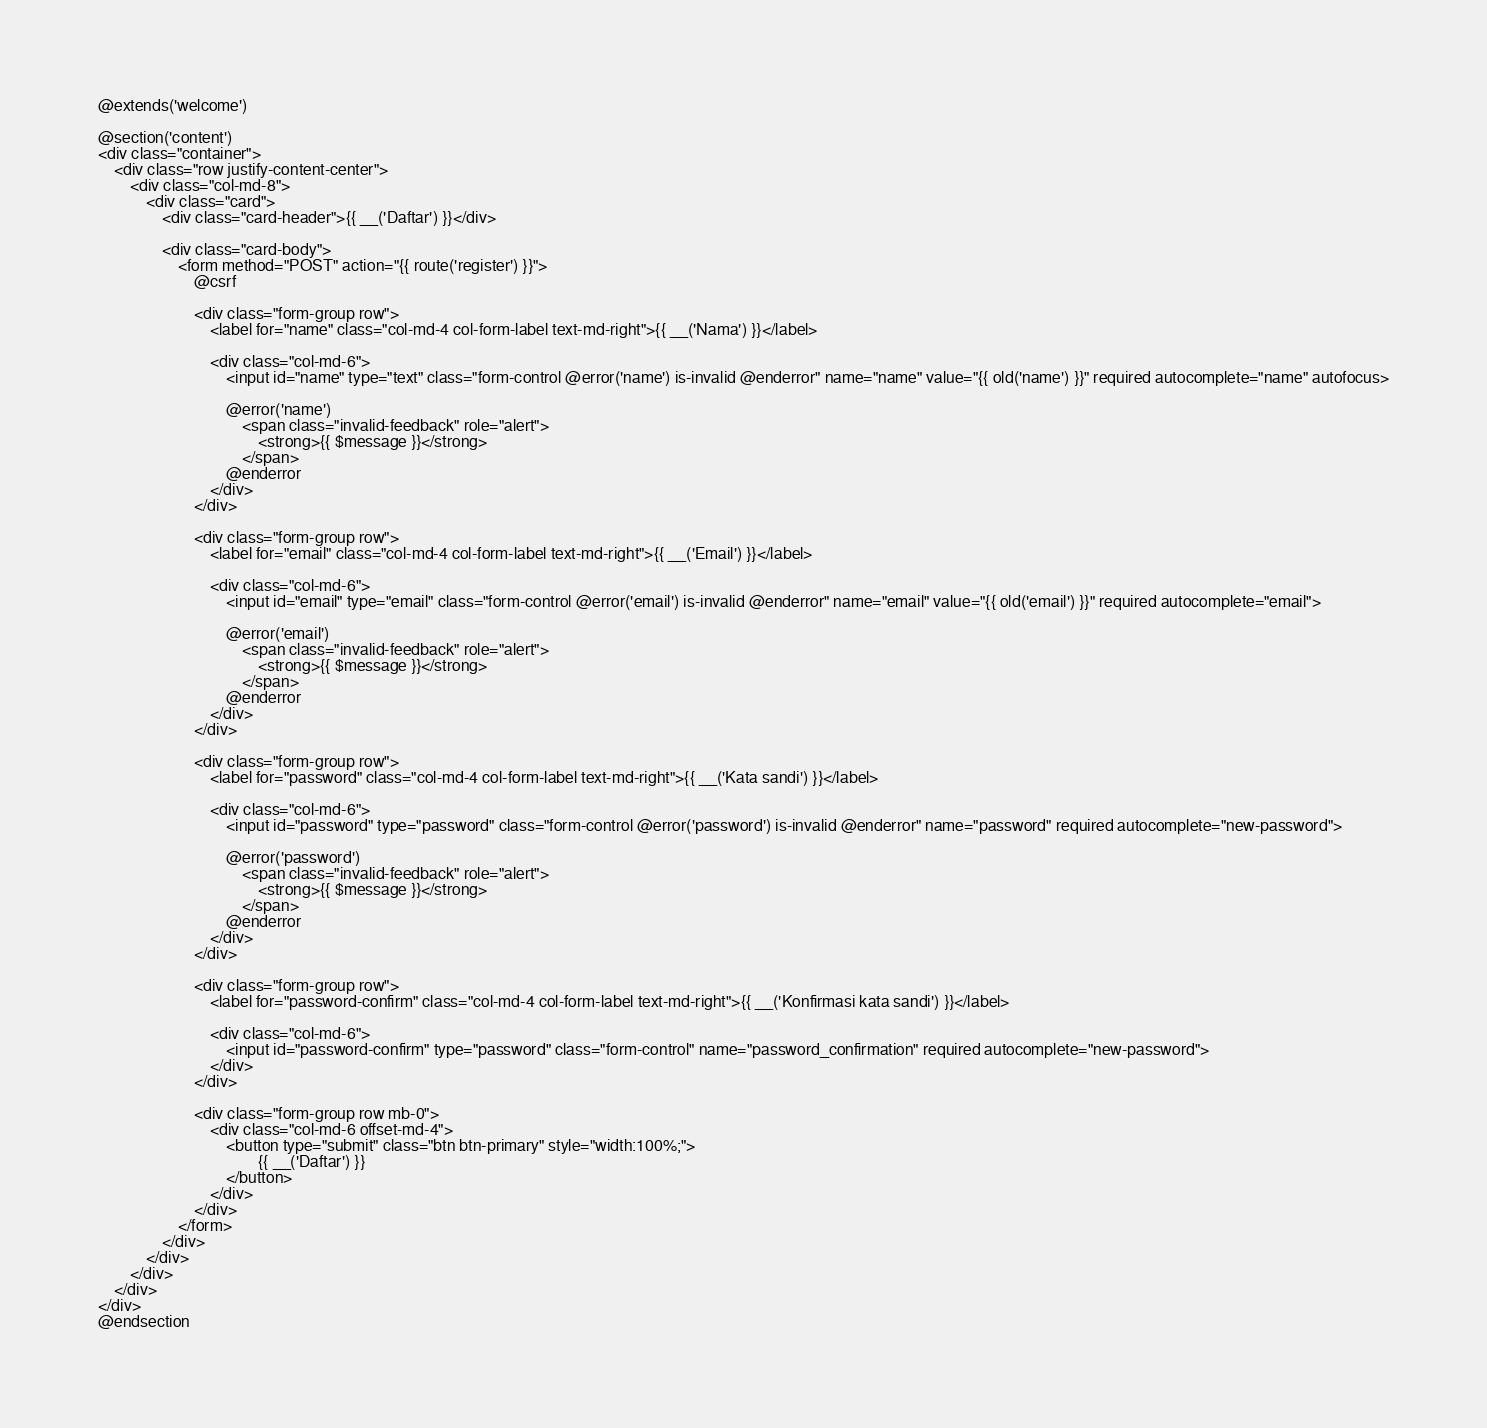Convert code to text. <code><loc_0><loc_0><loc_500><loc_500><_PHP_>@extends('welcome')

@section('content')
<div class="container">
    <div class="row justify-content-center">
        <div class="col-md-8">
            <div class="card">
                <div class="card-header">{{ __('Daftar') }}</div>

                <div class="card-body">
                    <form method="POST" action="{{ route('register') }}">
                        @csrf

                        <div class="form-group row">
                            <label for="name" class="col-md-4 col-form-label text-md-right">{{ __('Nama') }}</label>

                            <div class="col-md-6">
                                <input id="name" type="text" class="form-control @error('name') is-invalid @enderror" name="name" value="{{ old('name') }}" required autocomplete="name" autofocus>

                                @error('name')
                                    <span class="invalid-feedback" role="alert">
                                        <strong>{{ $message }}</strong>
                                    </span>
                                @enderror
                            </div>
                        </div>

                        <div class="form-group row">
                            <label for="email" class="col-md-4 col-form-label text-md-right">{{ __('Email') }}</label>

                            <div class="col-md-6">
                                <input id="email" type="email" class="form-control @error('email') is-invalid @enderror" name="email" value="{{ old('email') }}" required autocomplete="email">

                                @error('email')
                                    <span class="invalid-feedback" role="alert">
                                        <strong>{{ $message }}</strong>
                                    </span>
                                @enderror
                            </div>
                        </div>

                        <div class="form-group row">
                            <label for="password" class="col-md-4 col-form-label text-md-right">{{ __('Kata sandi') }}</label>

                            <div class="col-md-6">
                                <input id="password" type="password" class="form-control @error('password') is-invalid @enderror" name="password" required autocomplete="new-password">

                                @error('password')
                                    <span class="invalid-feedback" role="alert">
                                        <strong>{{ $message }}</strong>
                                    </span>
                                @enderror
                            </div>
                        </div>

                        <div class="form-group row">
                            <label for="password-confirm" class="col-md-4 col-form-label text-md-right">{{ __('Konfirmasi kata sandi') }}</label>

                            <div class="col-md-6">
                                <input id="password-confirm" type="password" class="form-control" name="password_confirmation" required autocomplete="new-password">
                            </div>
                        </div>

                        <div class="form-group row mb-0">
                            <div class="col-md-6 offset-md-4">
                                <button type="submit" class="btn btn-primary" style="width:100%;">
                                        {{ __('Daftar') }}
                                </button>
                            </div>
                        </div>
                    </form>
                </div>
            </div>
        </div>
    </div>
</div>
@endsection
</code> 